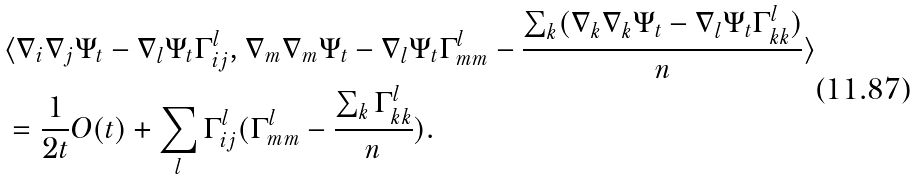Convert formula to latex. <formula><loc_0><loc_0><loc_500><loc_500>& \langle \nabla _ { i } \nabla _ { j } \Psi _ { t } - \nabla _ { l } \Psi _ { t } \Gamma _ { i j } ^ { l } , \nabla _ { m } \nabla _ { m } \Psi _ { t } - \nabla _ { l } \Psi _ { t } \Gamma _ { m m } ^ { l } - \frac { \sum _ { k } ( \nabla _ { k } \nabla _ { k } \Psi _ { t } - \nabla _ { l } \Psi _ { t } \Gamma _ { k k } ^ { l } ) } { n } \rangle \\ & = \frac { 1 } { 2 t } O ( t ) + \sum _ { l } \Gamma _ { i j } ^ { l } ( \Gamma _ { m m } ^ { l } - \frac { \sum _ { k } \Gamma ^ { l } _ { k k } } { n } ) .</formula> 